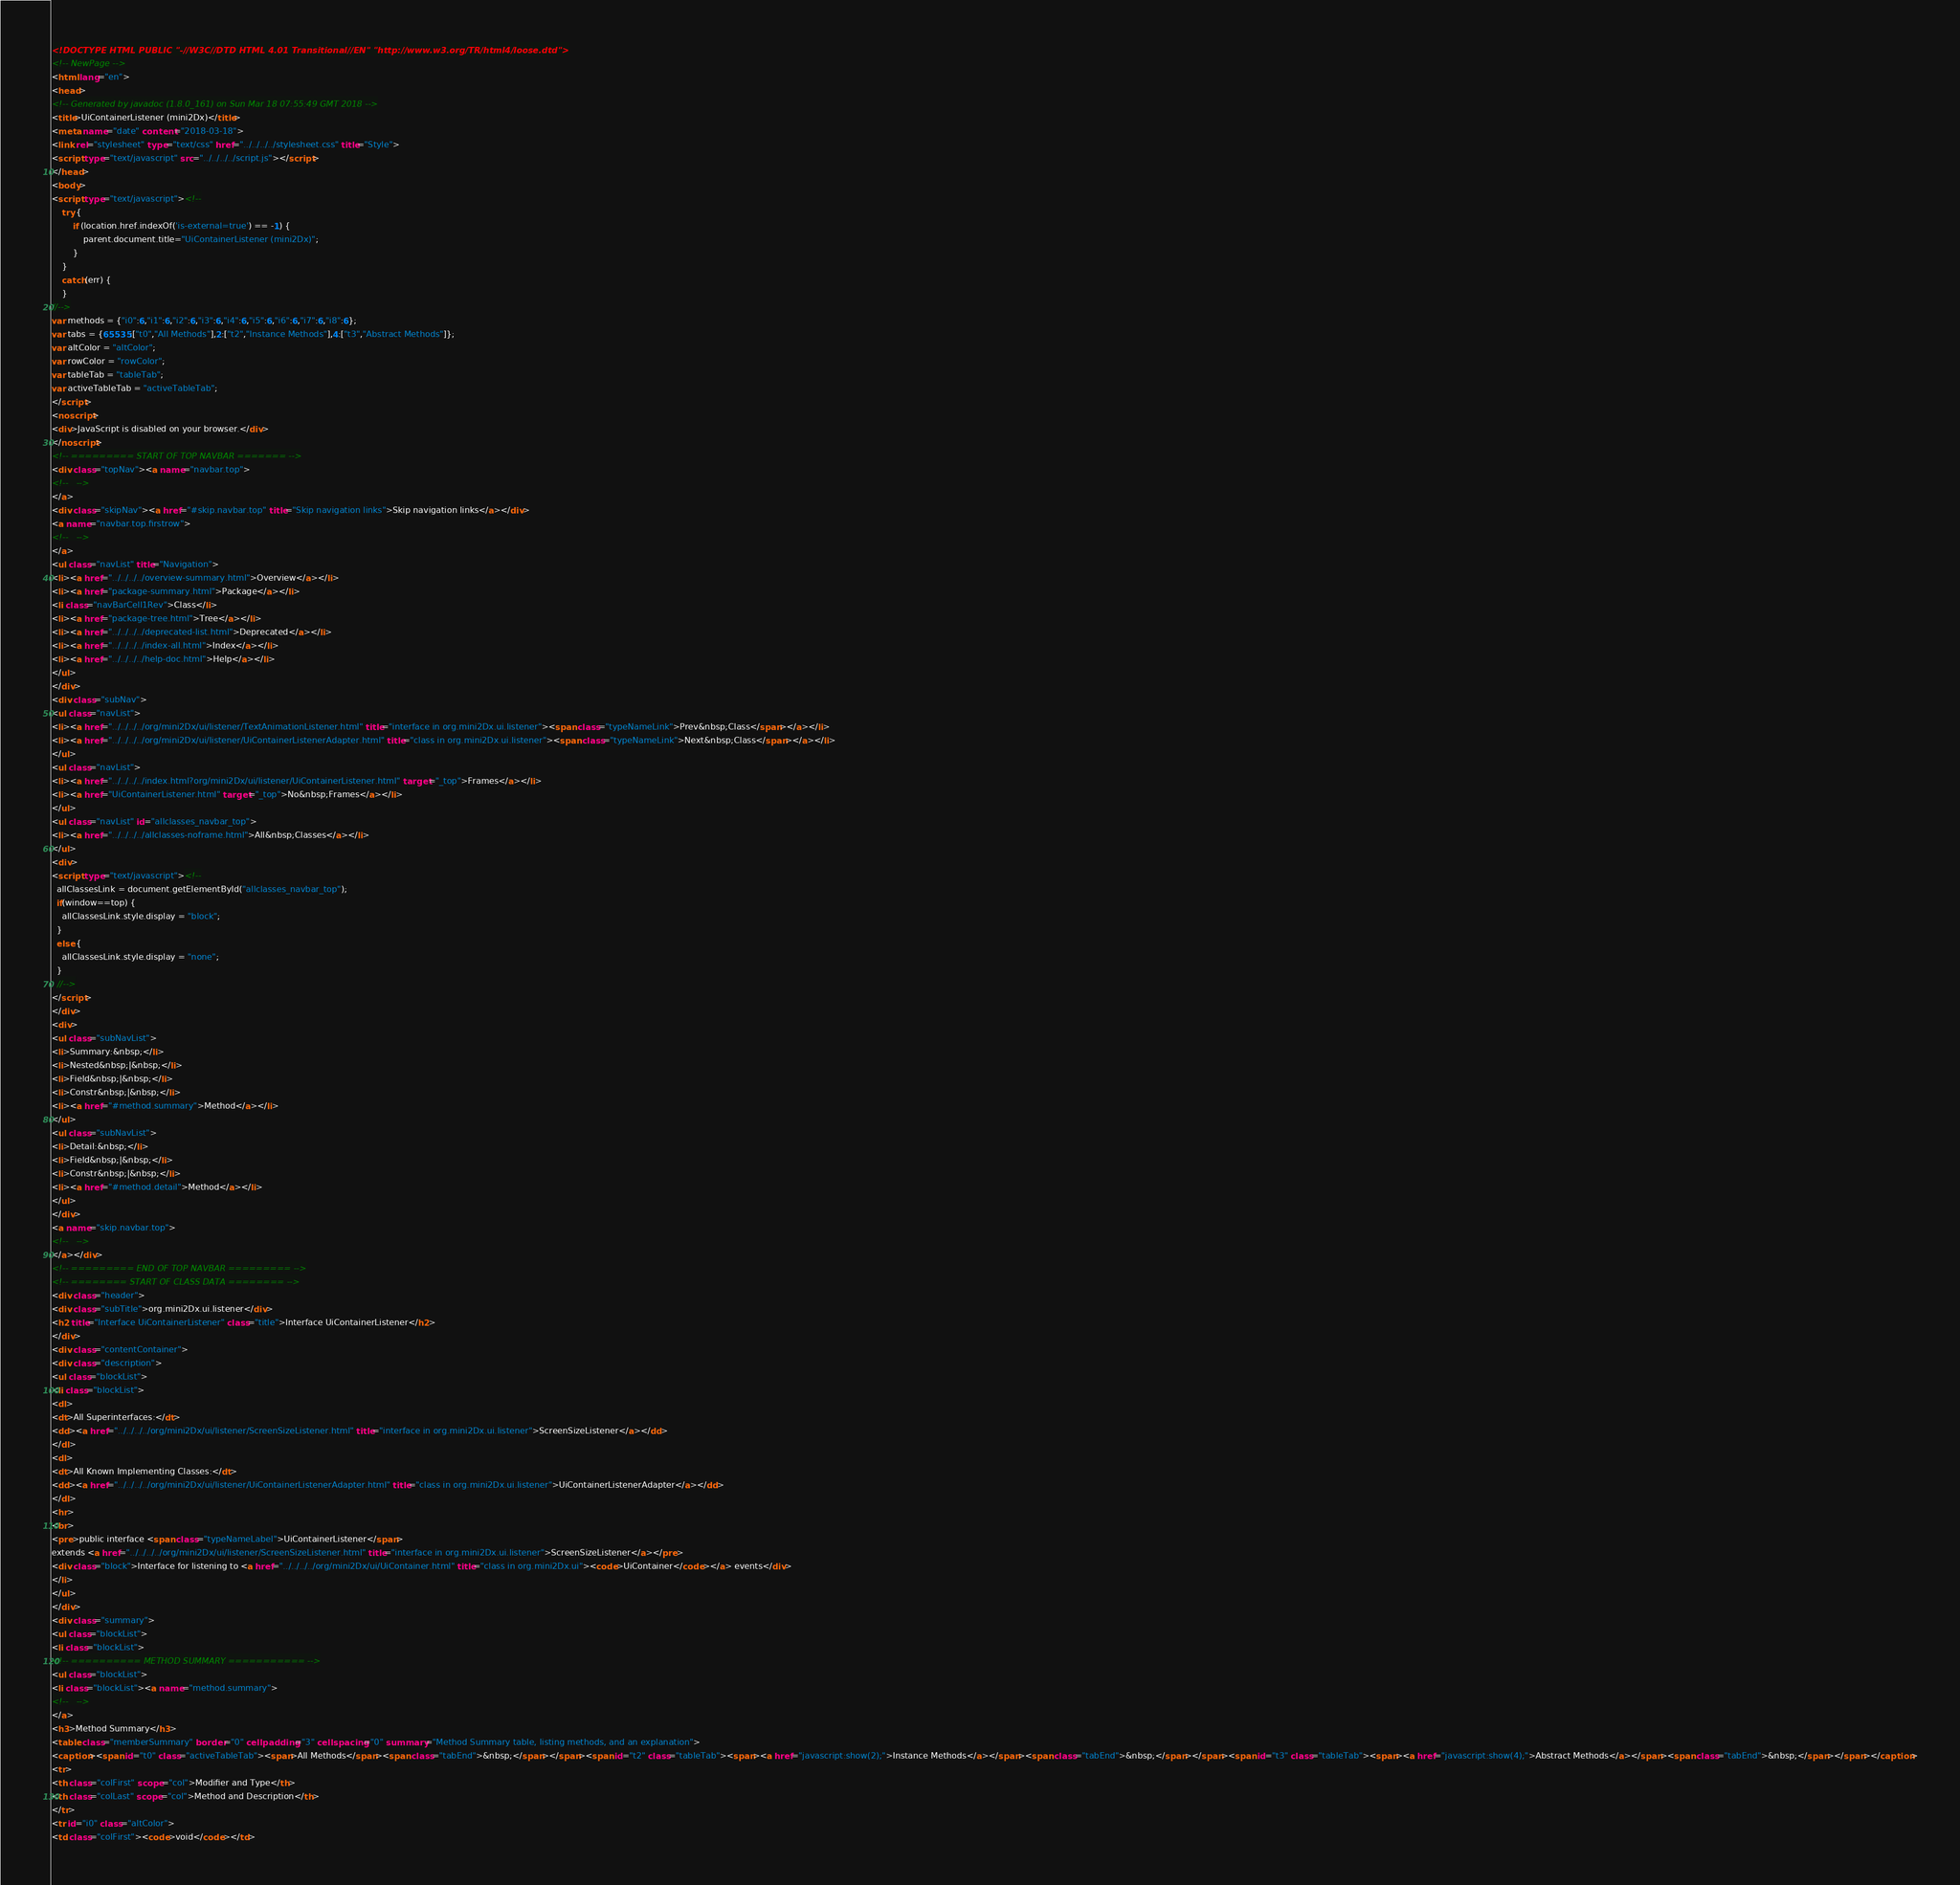<code> <loc_0><loc_0><loc_500><loc_500><_HTML_><!DOCTYPE HTML PUBLIC "-//W3C//DTD HTML 4.01 Transitional//EN" "http://www.w3.org/TR/html4/loose.dtd">
<!-- NewPage -->
<html lang="en">
<head>
<!-- Generated by javadoc (1.8.0_161) on Sun Mar 18 07:55:49 GMT 2018 -->
<title>UiContainerListener (mini2Dx)</title>
<meta name="date" content="2018-03-18">
<link rel="stylesheet" type="text/css" href="../../../../stylesheet.css" title="Style">
<script type="text/javascript" src="../../../../script.js"></script>
</head>
<body>
<script type="text/javascript"><!--
    try {
        if (location.href.indexOf('is-external=true') == -1) {
            parent.document.title="UiContainerListener (mini2Dx)";
        }
    }
    catch(err) {
    }
//-->
var methods = {"i0":6,"i1":6,"i2":6,"i3":6,"i4":6,"i5":6,"i6":6,"i7":6,"i8":6};
var tabs = {65535:["t0","All Methods"],2:["t2","Instance Methods"],4:["t3","Abstract Methods"]};
var altColor = "altColor";
var rowColor = "rowColor";
var tableTab = "tableTab";
var activeTableTab = "activeTableTab";
</script>
<noscript>
<div>JavaScript is disabled on your browser.</div>
</noscript>
<!-- ========= START OF TOP NAVBAR ======= -->
<div class="topNav"><a name="navbar.top">
<!--   -->
</a>
<div class="skipNav"><a href="#skip.navbar.top" title="Skip navigation links">Skip navigation links</a></div>
<a name="navbar.top.firstrow">
<!--   -->
</a>
<ul class="navList" title="Navigation">
<li><a href="../../../../overview-summary.html">Overview</a></li>
<li><a href="package-summary.html">Package</a></li>
<li class="navBarCell1Rev">Class</li>
<li><a href="package-tree.html">Tree</a></li>
<li><a href="../../../../deprecated-list.html">Deprecated</a></li>
<li><a href="../../../../index-all.html">Index</a></li>
<li><a href="../../../../help-doc.html">Help</a></li>
</ul>
</div>
<div class="subNav">
<ul class="navList">
<li><a href="../../../../org/mini2Dx/ui/listener/TextAnimationListener.html" title="interface in org.mini2Dx.ui.listener"><span class="typeNameLink">Prev&nbsp;Class</span></a></li>
<li><a href="../../../../org/mini2Dx/ui/listener/UiContainerListenerAdapter.html" title="class in org.mini2Dx.ui.listener"><span class="typeNameLink">Next&nbsp;Class</span></a></li>
</ul>
<ul class="navList">
<li><a href="../../../../index.html?org/mini2Dx/ui/listener/UiContainerListener.html" target="_top">Frames</a></li>
<li><a href="UiContainerListener.html" target="_top">No&nbsp;Frames</a></li>
</ul>
<ul class="navList" id="allclasses_navbar_top">
<li><a href="../../../../allclasses-noframe.html">All&nbsp;Classes</a></li>
</ul>
<div>
<script type="text/javascript"><!--
  allClassesLink = document.getElementById("allclasses_navbar_top");
  if(window==top) {
    allClassesLink.style.display = "block";
  }
  else {
    allClassesLink.style.display = "none";
  }
  //-->
</script>
</div>
<div>
<ul class="subNavList">
<li>Summary:&nbsp;</li>
<li>Nested&nbsp;|&nbsp;</li>
<li>Field&nbsp;|&nbsp;</li>
<li>Constr&nbsp;|&nbsp;</li>
<li><a href="#method.summary">Method</a></li>
</ul>
<ul class="subNavList">
<li>Detail:&nbsp;</li>
<li>Field&nbsp;|&nbsp;</li>
<li>Constr&nbsp;|&nbsp;</li>
<li><a href="#method.detail">Method</a></li>
</ul>
</div>
<a name="skip.navbar.top">
<!--   -->
</a></div>
<!-- ========= END OF TOP NAVBAR ========= -->
<!-- ======== START OF CLASS DATA ======== -->
<div class="header">
<div class="subTitle">org.mini2Dx.ui.listener</div>
<h2 title="Interface UiContainerListener" class="title">Interface UiContainerListener</h2>
</div>
<div class="contentContainer">
<div class="description">
<ul class="blockList">
<li class="blockList">
<dl>
<dt>All Superinterfaces:</dt>
<dd><a href="../../../../org/mini2Dx/ui/listener/ScreenSizeListener.html" title="interface in org.mini2Dx.ui.listener">ScreenSizeListener</a></dd>
</dl>
<dl>
<dt>All Known Implementing Classes:</dt>
<dd><a href="../../../../org/mini2Dx/ui/listener/UiContainerListenerAdapter.html" title="class in org.mini2Dx.ui.listener">UiContainerListenerAdapter</a></dd>
</dl>
<hr>
<br>
<pre>public interface <span class="typeNameLabel">UiContainerListener</span>
extends <a href="../../../../org/mini2Dx/ui/listener/ScreenSizeListener.html" title="interface in org.mini2Dx.ui.listener">ScreenSizeListener</a></pre>
<div class="block">Interface for listening to <a href="../../../../org/mini2Dx/ui/UiContainer.html" title="class in org.mini2Dx.ui"><code>UiContainer</code></a> events</div>
</li>
</ul>
</div>
<div class="summary">
<ul class="blockList">
<li class="blockList">
<!-- ========== METHOD SUMMARY =========== -->
<ul class="blockList">
<li class="blockList"><a name="method.summary">
<!--   -->
</a>
<h3>Method Summary</h3>
<table class="memberSummary" border="0" cellpadding="3" cellspacing="0" summary="Method Summary table, listing methods, and an explanation">
<caption><span id="t0" class="activeTableTab"><span>All Methods</span><span class="tabEnd">&nbsp;</span></span><span id="t2" class="tableTab"><span><a href="javascript:show(2);">Instance Methods</a></span><span class="tabEnd">&nbsp;</span></span><span id="t3" class="tableTab"><span><a href="javascript:show(4);">Abstract Methods</a></span><span class="tabEnd">&nbsp;</span></span></caption>
<tr>
<th class="colFirst" scope="col">Modifier and Type</th>
<th class="colLast" scope="col">Method and Description</th>
</tr>
<tr id="i0" class="altColor">
<td class="colFirst"><code>void</code></td></code> 